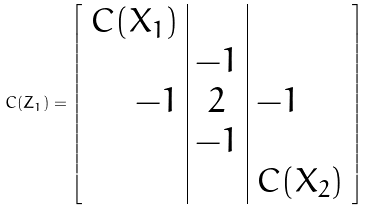Convert formula to latex. <formula><loc_0><loc_0><loc_500><loc_500>C ( Z _ { 1 } ) = \left [ \begin{array} { r | c | l } C ( X _ { 1 } ) & & \\ & - 1 & \\ - 1 & 2 & - 1 \\ & - 1 & \\ & & C ( X _ { 2 } ) \\ \end{array} \right ]</formula> 